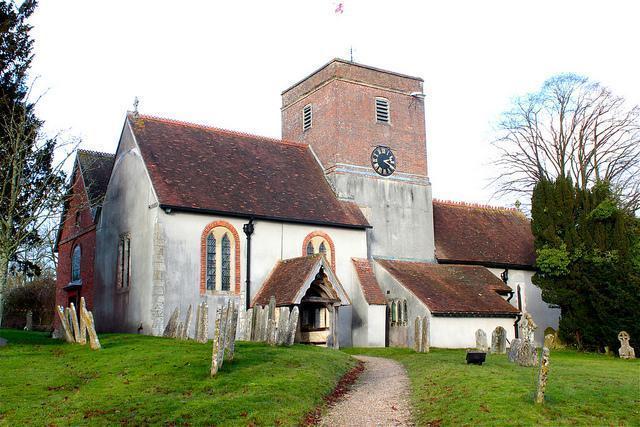How many windows are shown on the front of the house?
Give a very brief answer. 4. 